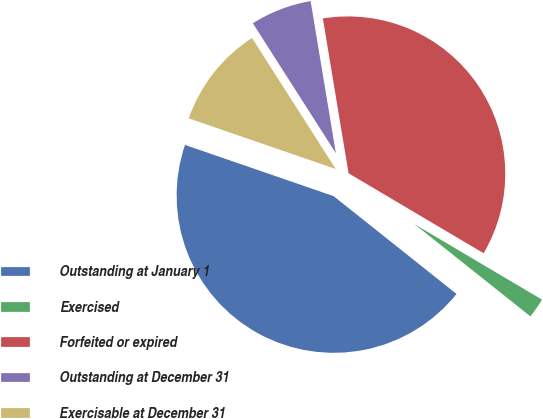<chart> <loc_0><loc_0><loc_500><loc_500><pie_chart><fcel>Outstanding at January 1<fcel>Exercised<fcel>Forfeited or expired<fcel>Outstanding at December 31<fcel>Exercisable at December 31<nl><fcel>44.59%<fcel>2.19%<fcel>36.13%<fcel>6.43%<fcel>10.67%<nl></chart> 